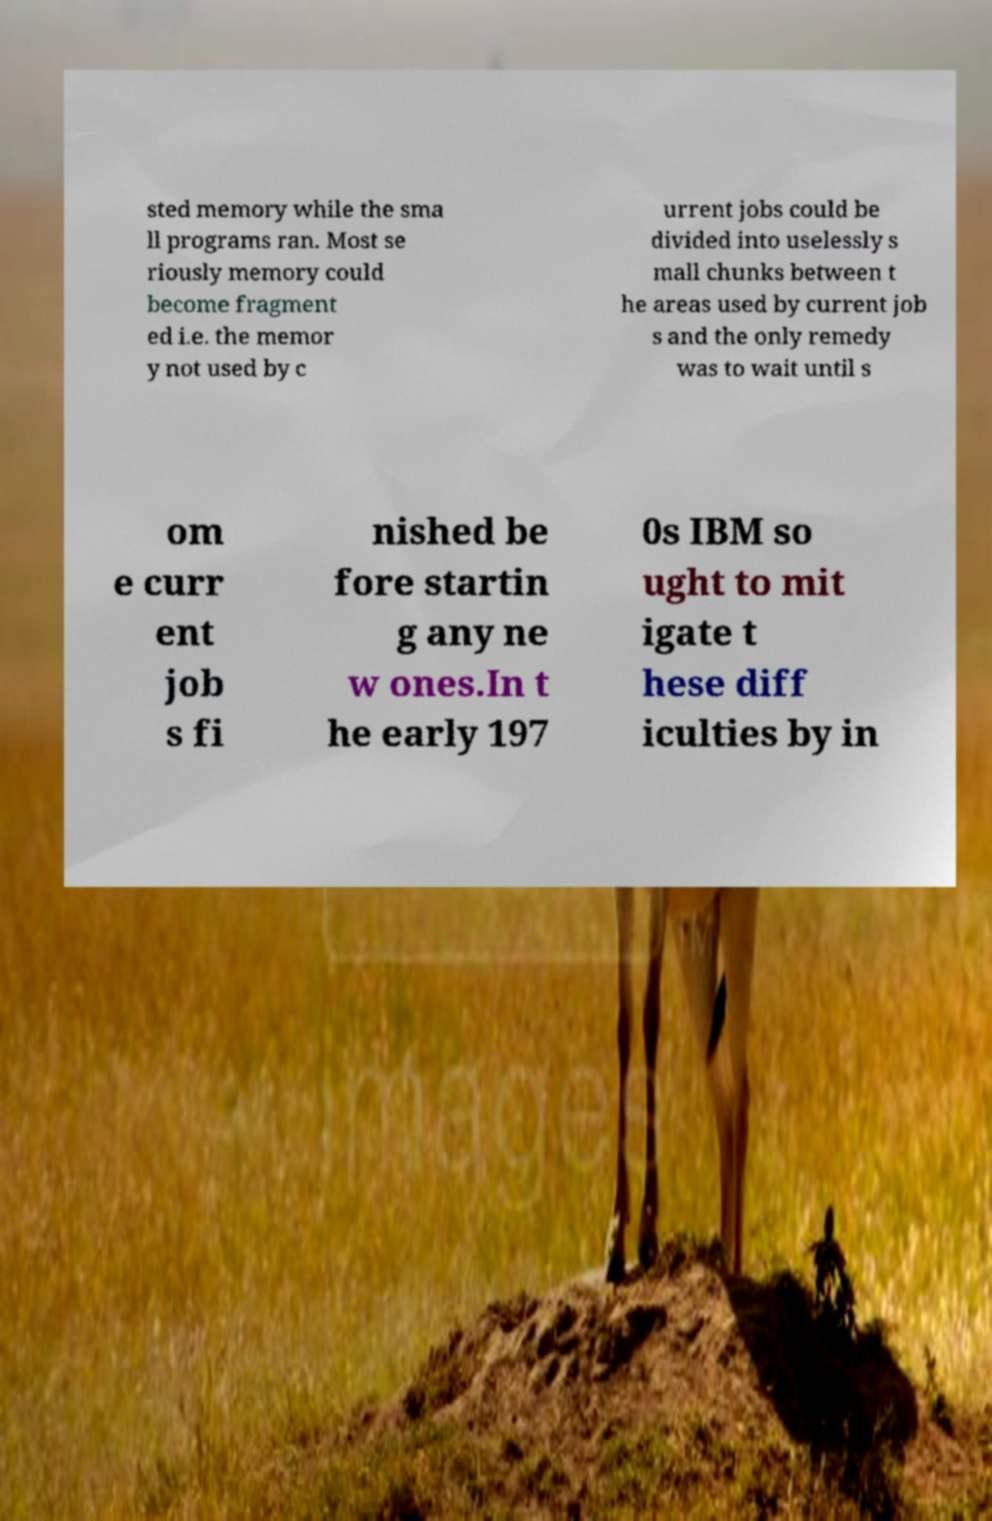Please read and relay the text visible in this image. What does it say? sted memory while the sma ll programs ran. Most se riously memory could become fragment ed i.e. the memor y not used by c urrent jobs could be divided into uselessly s mall chunks between t he areas used by current job s and the only remedy was to wait until s om e curr ent job s fi nished be fore startin g any ne w ones.In t he early 197 0s IBM so ught to mit igate t hese diff iculties by in 